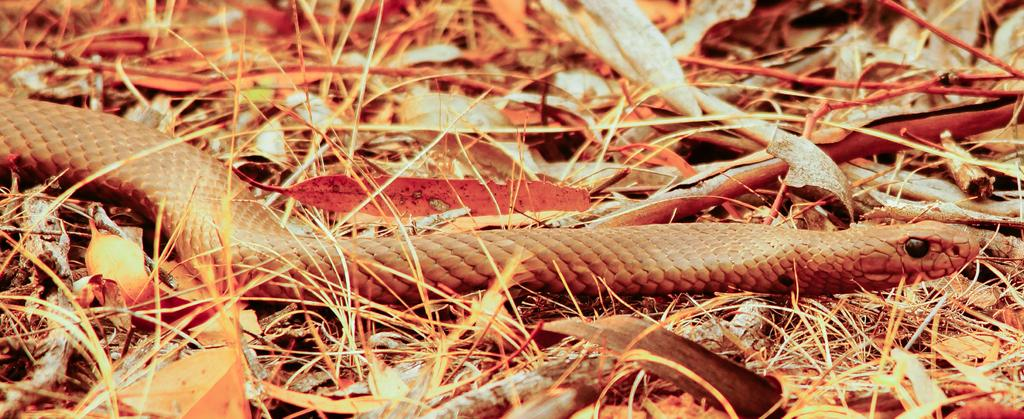What type of animal is in the image? There is a snake in the image. What can be seen around the snake? Dried leaves, grass, and twigs are present around the snake. How much money does the snake have in its business in the image? There is no indication of a business or money in the image; it features a snake surrounded by dried leaves, grass, and twigs. 